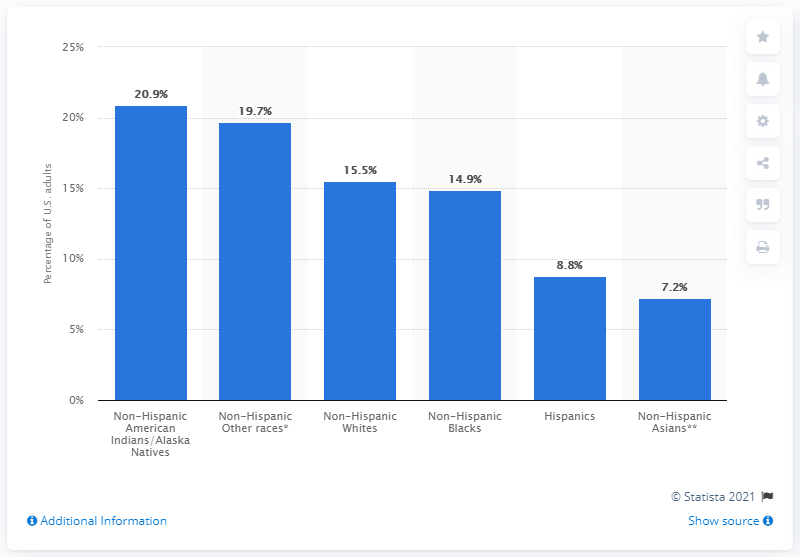Identify some key points in this picture. In 2019, the smoking rate among American Indians/Alaska Natives was 20.9%. 